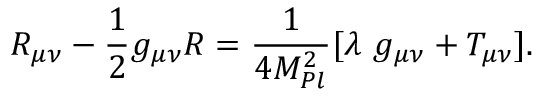Convert formula to latex. <formula><loc_0><loc_0><loc_500><loc_500>R _ { \mu \nu } - \frac { 1 } { 2 } g _ { \mu \nu } R = \frac { 1 } { 4 M _ { P l } ^ { 2 } } [ \lambda g _ { \mu \nu } + T _ { \mu \nu } ] .</formula> 